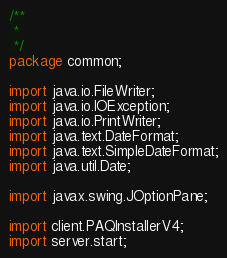<code> <loc_0><loc_0><loc_500><loc_500><_Java_>/**
 * 
 */
package common;

import java.io.FileWriter;
import java.io.IOException;
import java.io.PrintWriter;
import java.text.DateFormat;
import java.text.SimpleDateFormat;
import java.util.Date;

import javax.swing.JOptionPane;

import client.PAQInstallerV4;
import server.start;</code> 